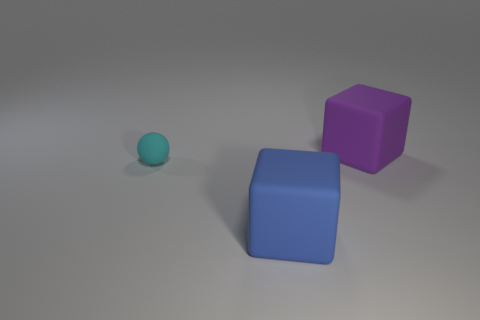Add 2 tiny brown rubber cylinders. How many objects exist? 5 Subtract all purple blocks. How many blocks are left? 1 Subtract 1 cubes. How many cubes are left? 1 Subtract all spheres. How many objects are left? 2 Add 1 big purple things. How many big purple things are left? 2 Add 1 small rubber spheres. How many small rubber spheres exist? 2 Subtract 0 green cylinders. How many objects are left? 3 Subtract all cyan blocks. Subtract all yellow cylinders. How many blocks are left? 2 Subtract all cyan spheres. Subtract all rubber blocks. How many objects are left? 0 